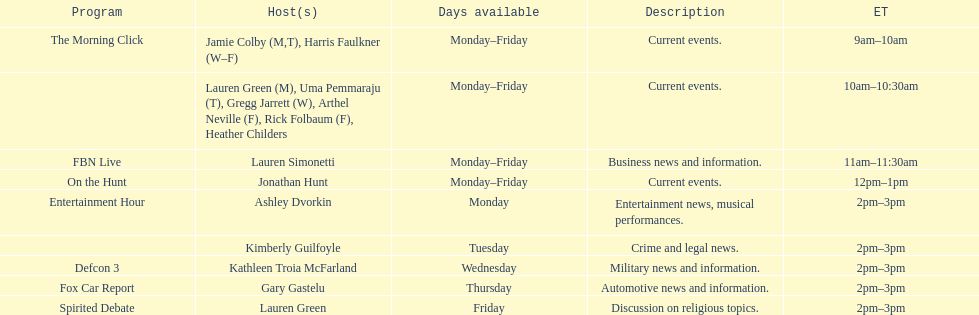Can you parse all the data within this table? {'header': ['Program', 'Host(s)', 'Days available', 'Description', 'ET'], 'rows': [['The Morning Click', 'Jamie Colby (M,T), Harris Faulkner (W–F)', 'Monday–Friday', 'Current events.', '9am–10am'], ['', 'Lauren Green (M), Uma Pemmaraju (T), Gregg Jarrett (W), Arthel Neville (F), Rick Folbaum (F), Heather Childers', 'Monday–Friday', 'Current events.', '10am–10:30am'], ['FBN Live', 'Lauren Simonetti', 'Monday–Friday', 'Business news and information.', '11am–11:30am'], ['On the Hunt', 'Jonathan Hunt', 'Monday–Friday', 'Current events.', '12pm–1pm'], ['Entertainment Hour', 'Ashley Dvorkin', 'Monday', 'Entertainment news, musical performances.', '2pm–3pm'], ['', 'Kimberly Guilfoyle', 'Tuesday', 'Crime and legal news.', '2pm–3pm'], ['Defcon 3', 'Kathleen Troia McFarland', 'Wednesday', 'Military news and information.', '2pm–3pm'], ['Fox Car Report', 'Gary Gastelu', 'Thursday', 'Automotive news and information.', '2pm–3pm'], ['Spirited Debate', 'Lauren Green', 'Friday', 'Discussion on religious topics.', '2pm–3pm']]} Who are all of the hosts? Jamie Colby (M,T), Harris Faulkner (W–F), Lauren Green (M), Uma Pemmaraju (T), Gregg Jarrett (W), Arthel Neville (F), Rick Folbaum (F), Heather Childers, Lauren Simonetti, Jonathan Hunt, Ashley Dvorkin, Kimberly Guilfoyle, Kathleen Troia McFarland, Gary Gastelu, Lauren Green. Which hosts have shows on fridays? Jamie Colby (M,T), Harris Faulkner (W–F), Lauren Green (M), Uma Pemmaraju (T), Gregg Jarrett (W), Arthel Neville (F), Rick Folbaum (F), Heather Childers, Lauren Simonetti, Jonathan Hunt, Lauren Green. Of those, which host's show airs at 2pm? Lauren Green. 